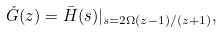<formula> <loc_0><loc_0><loc_500><loc_500>\check { G } ( z ) = \bar { H } ( s ) | _ { s = 2 \Omega ( z - 1 ) / ( z + 1 ) } ,</formula> 